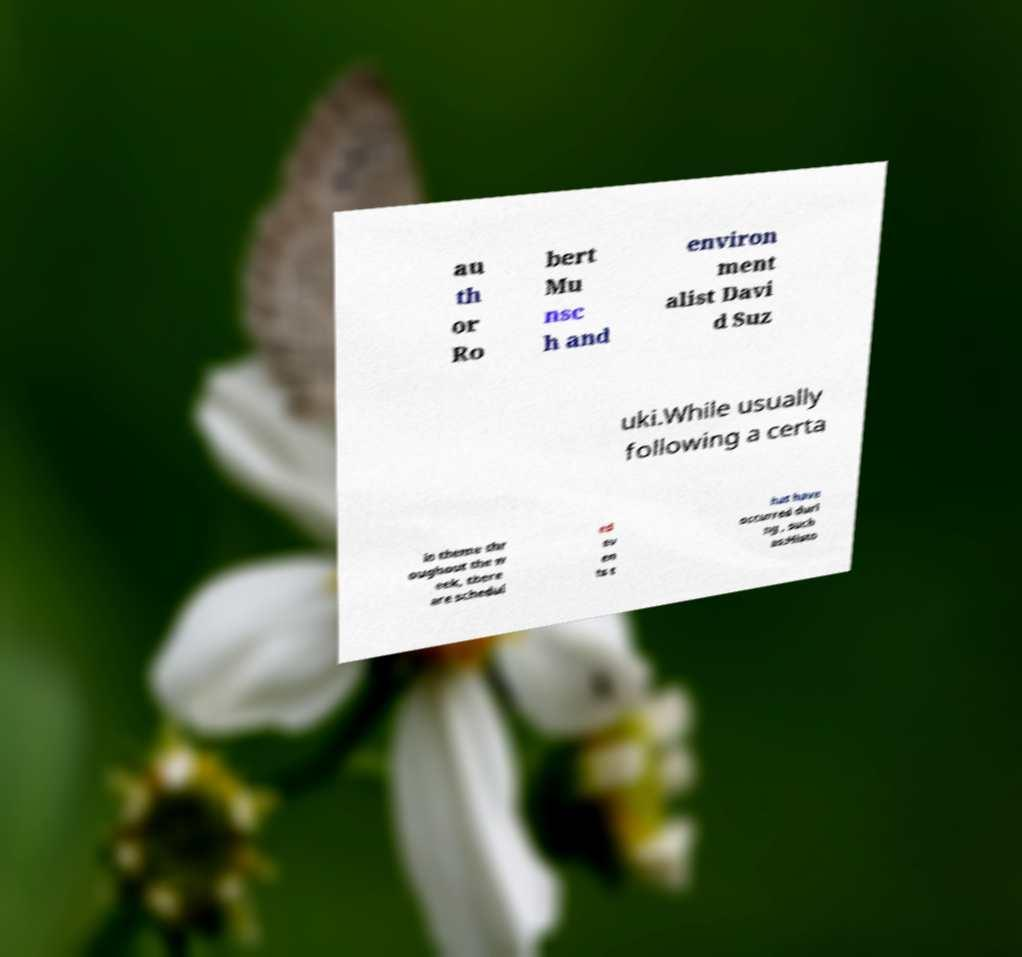Can you accurately transcribe the text from the provided image for me? au th or Ro bert Mu nsc h and environ ment alist Davi d Suz uki.While usually following a certa in theme thr oughout the w eek, there are schedul ed ev en ts t hat have occurred duri ng , such as:Histo 